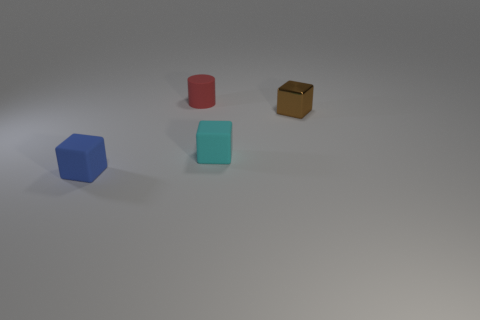There is a cylinder that is the same size as the blue matte block; what is its color?
Your response must be concise. Red. Are there fewer shiny objects left of the tiny cyan object than cyan blocks on the right side of the brown shiny cube?
Your response must be concise. No. There is a rubber block in front of the rubber cube that is to the right of the small blue block; what number of cubes are behind it?
Provide a succinct answer. 2. The brown object that is the same shape as the blue object is what size?
Your response must be concise. Small. Is there anything else that has the same size as the red thing?
Your answer should be compact. Yes. Are there fewer tiny blue blocks to the right of the tiny cylinder than large brown metallic cylinders?
Make the answer very short. No. Do the tiny red matte object and the small cyan thing have the same shape?
Ensure brevity in your answer.  No. There is another matte thing that is the same shape as the small cyan matte thing; what is its color?
Ensure brevity in your answer.  Blue. How many other cylinders have the same color as the cylinder?
Give a very brief answer. 0. What number of things are small matte cubes to the left of the tiny cyan rubber cube or blue rubber blocks?
Give a very brief answer. 1. 